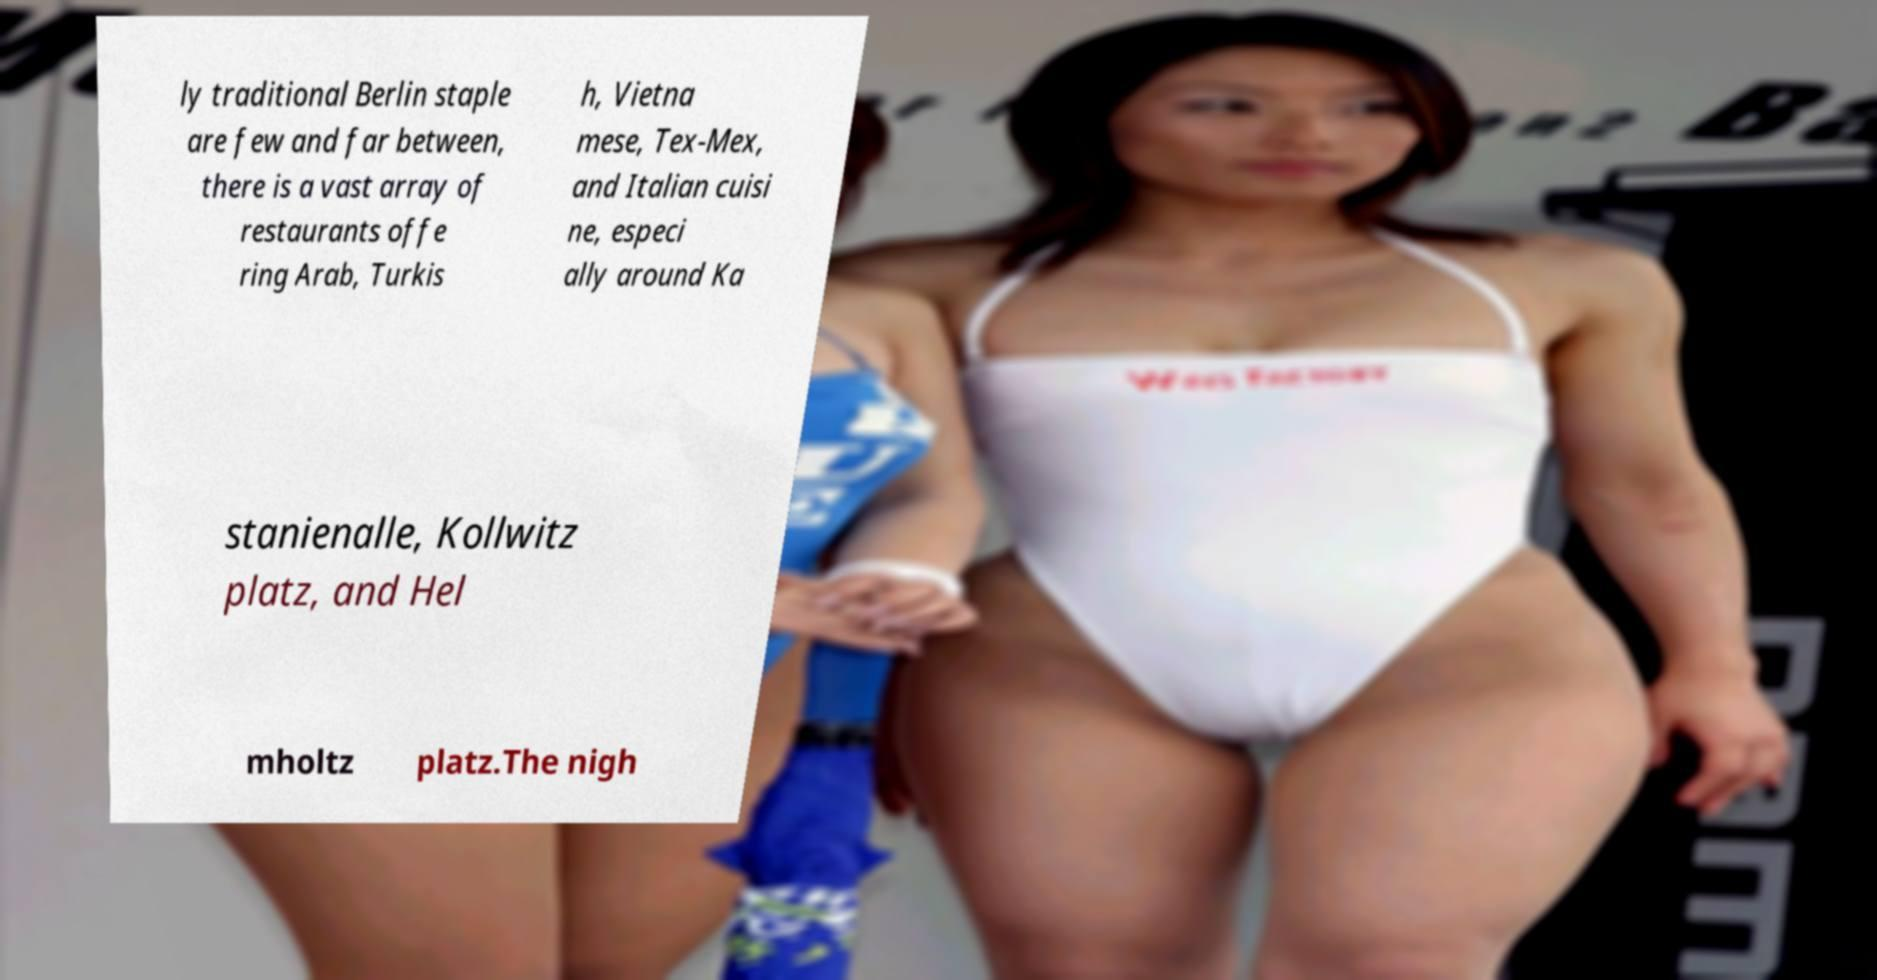Can you read and provide the text displayed in the image?This photo seems to have some interesting text. Can you extract and type it out for me? ly traditional Berlin staple are few and far between, there is a vast array of restaurants offe ring Arab, Turkis h, Vietna mese, Tex-Mex, and Italian cuisi ne, especi ally around Ka stanienalle, Kollwitz platz, and Hel mholtz platz.The nigh 